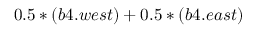Convert formula to latex. <formula><loc_0><loc_0><loc_500><loc_500>0 . 5 * ( b 4 . w e s t ) + 0 . 5 * ( b 4 . e a s t )</formula> 